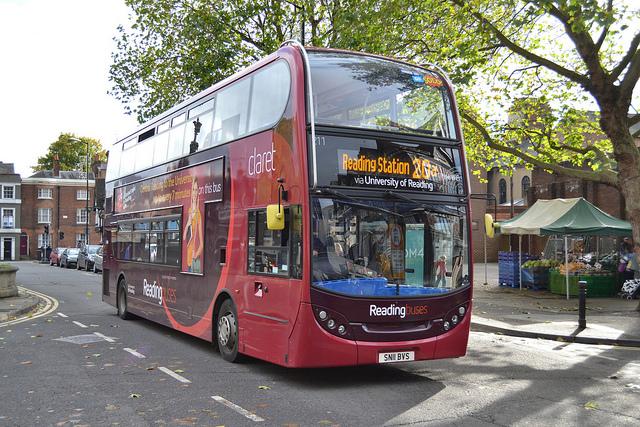What color is the bus?
Short answer required. Red. How many levels are on the bus?
Be succinct. 2. What color is the tree?
Keep it brief. Green. 